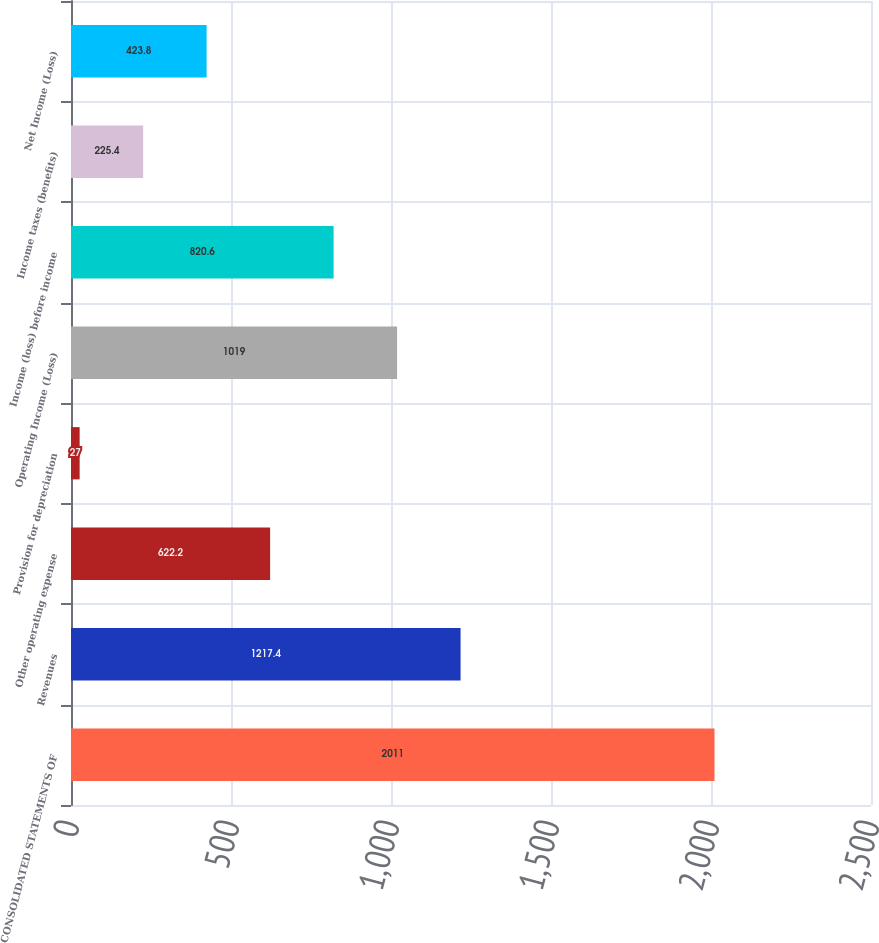Convert chart to OTSL. <chart><loc_0><loc_0><loc_500><loc_500><bar_chart><fcel>CONSOLIDATED STATEMENTS OF<fcel>Revenues<fcel>Other operating expense<fcel>Provision for depreciation<fcel>Operating Income (Loss)<fcel>Income (loss) before income<fcel>Income taxes (benefits)<fcel>Net Income (Loss)<nl><fcel>2011<fcel>1217.4<fcel>622.2<fcel>27<fcel>1019<fcel>820.6<fcel>225.4<fcel>423.8<nl></chart> 